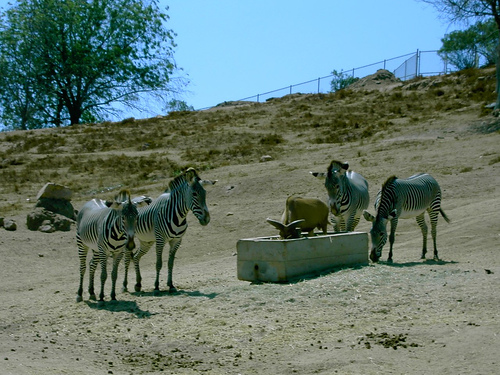<image>What liquid does this animal produce for humans? I am not sure what liquid this animal produces for humans. It could be milk or none. What liquid does this animal produce for humans? This animal produces milk for humans. 